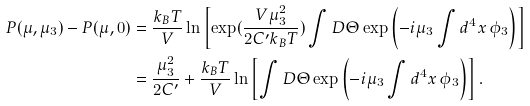<formula> <loc_0><loc_0><loc_500><loc_500>P ( \mu , \mu _ { 3 } ) - P ( \mu , 0 ) & = \frac { k _ { B } T } { V } \ln \left [ \exp ( \frac { V \mu _ { 3 } ^ { 2 } } { 2 C ^ { \prime } k _ { B } T } ) \int D \Theta \exp \left ( - i \mu _ { 3 } \int d ^ { 4 } x \, \phi _ { 3 } \right ) \right ] \\ & = \frac { \mu _ { 3 } ^ { 2 } } { 2 C ^ { \prime } } + \frac { k _ { B } T } { V } \ln \left [ \int D \Theta \exp \left ( - i \mu _ { 3 } \int d ^ { 4 } x \, \phi _ { 3 } \right ) \right ] .</formula> 